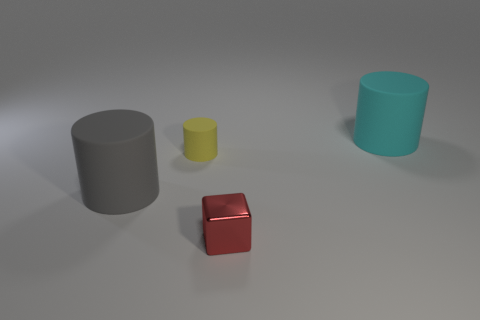There is a yellow rubber object that is the same shape as the cyan object; what size is it?
Provide a short and direct response. Small. There is a cylinder that is right of the metallic thing; does it have the same size as the metal block right of the small rubber cylinder?
Ensure brevity in your answer.  No. How many other things are there of the same material as the cyan cylinder?
Your response must be concise. 2. Is there any other thing that has the same shape as the tiny red metallic object?
Ensure brevity in your answer.  No. Does the block have the same size as the yellow matte thing?
Your answer should be compact. Yes. There is another big cylinder that is the same material as the cyan cylinder; what is its color?
Your response must be concise. Gray. Is the number of small things behind the tiny rubber cylinder less than the number of cubes behind the large cyan rubber cylinder?
Provide a succinct answer. No. What number of other small metal things are the same color as the metal thing?
Offer a very short reply. 0. What number of things are behind the tiny red metal object and right of the yellow rubber thing?
Your answer should be compact. 1. What material is the thing that is in front of the big matte cylinder that is on the left side of the cyan cylinder?
Offer a very short reply. Metal. 